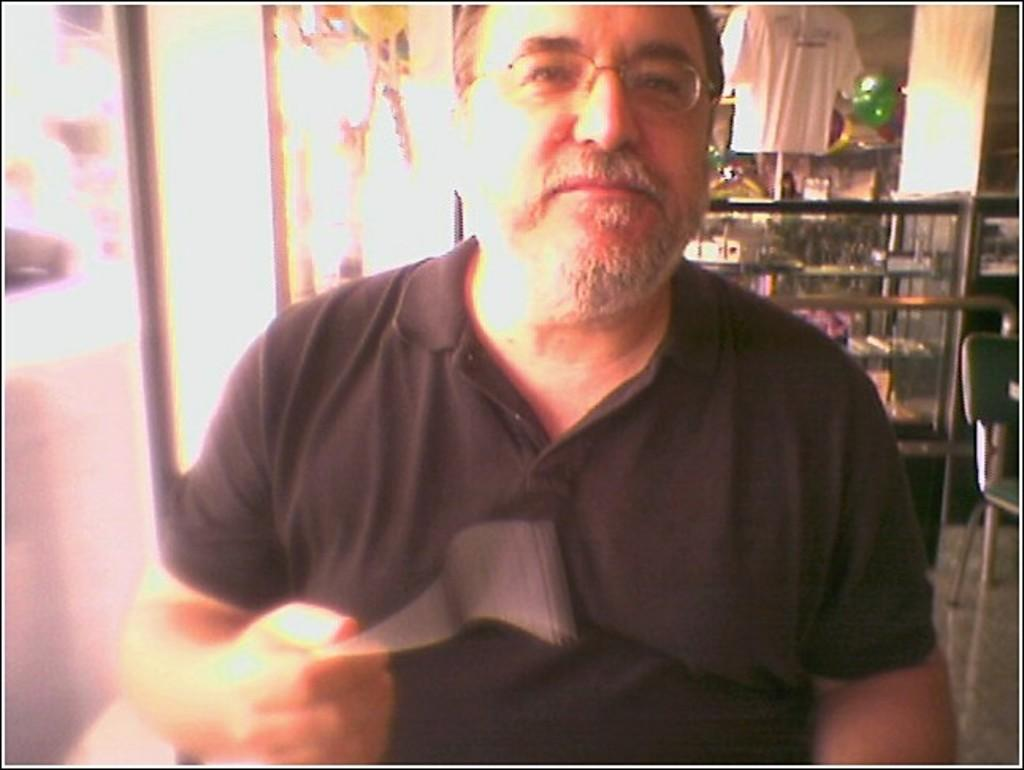What is the person in the foreground wearing? The person in the foreground is wearing a black t-shirt. What can be seen on the left side of the image? There is a window on the left side of the image. What type of objects are visible in the background? There are glass objects in the background. What structures are present in the background? There are racks and a pillar in the background. What type of surface is visible in the background? There is a wall in the background. What type of cactus can be seen providing shade in the image? There is no cactus present in the image, nor is there any shade provided by a cactus. 